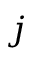<formula> <loc_0><loc_0><loc_500><loc_500>j</formula> 